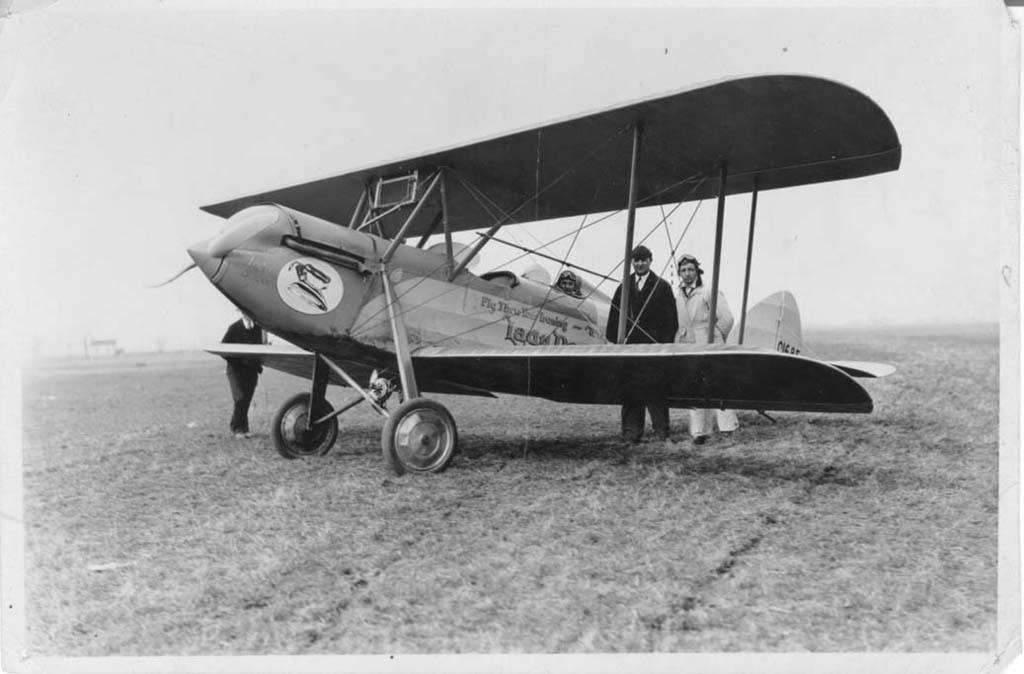What is the color scheme of the image? The image is black and white. What is the main subject in the image? There is a chopper in the image. Are there any people present in the image? Yes, two people are standing beside the chopper. What is the terrain like in the image? The land is covered with grass. Can you see the badge on the chopper in the image? There is no badge visible on the chopper in the image. How does the chopper manage to take flight in the image? The image is a still photograph and does not show the chopper in motion or taking flight. 